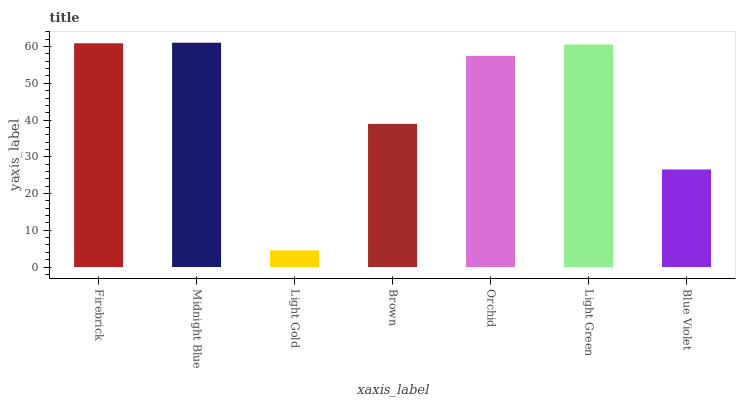Is Light Gold the minimum?
Answer yes or no. Yes. Is Midnight Blue the maximum?
Answer yes or no. Yes. Is Midnight Blue the minimum?
Answer yes or no. No. Is Light Gold the maximum?
Answer yes or no. No. Is Midnight Blue greater than Light Gold?
Answer yes or no. Yes. Is Light Gold less than Midnight Blue?
Answer yes or no. Yes. Is Light Gold greater than Midnight Blue?
Answer yes or no. No. Is Midnight Blue less than Light Gold?
Answer yes or no. No. Is Orchid the high median?
Answer yes or no. Yes. Is Orchid the low median?
Answer yes or no. Yes. Is Light Green the high median?
Answer yes or no. No. Is Blue Violet the low median?
Answer yes or no. No. 